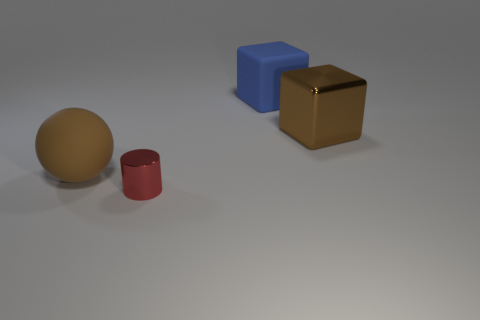Is there anything else that has the same size as the metal cylinder?
Your response must be concise. No. Is the red thing made of the same material as the blue thing?
Your answer should be very brief. No. There is a brown object that is in front of the brown object that is behind the big rubber thing in front of the large shiny thing; what shape is it?
Give a very brief answer. Sphere. Do the big thing on the left side of the tiny cylinder and the blue block to the right of the metal cylinder have the same material?
Give a very brief answer. Yes. What material is the red thing?
Offer a very short reply. Metal. How many other things have the same shape as the big metallic thing?
Give a very brief answer. 1. There is a object that is the same color as the matte ball; what material is it?
Provide a succinct answer. Metal. Is there anything else that has the same shape as the blue object?
Ensure brevity in your answer.  Yes. What color is the big object to the left of the tiny red thing in front of the metallic object that is on the right side of the tiny red metallic thing?
Ensure brevity in your answer.  Brown. What number of large things are either metal objects or rubber cubes?
Offer a terse response. 2. 